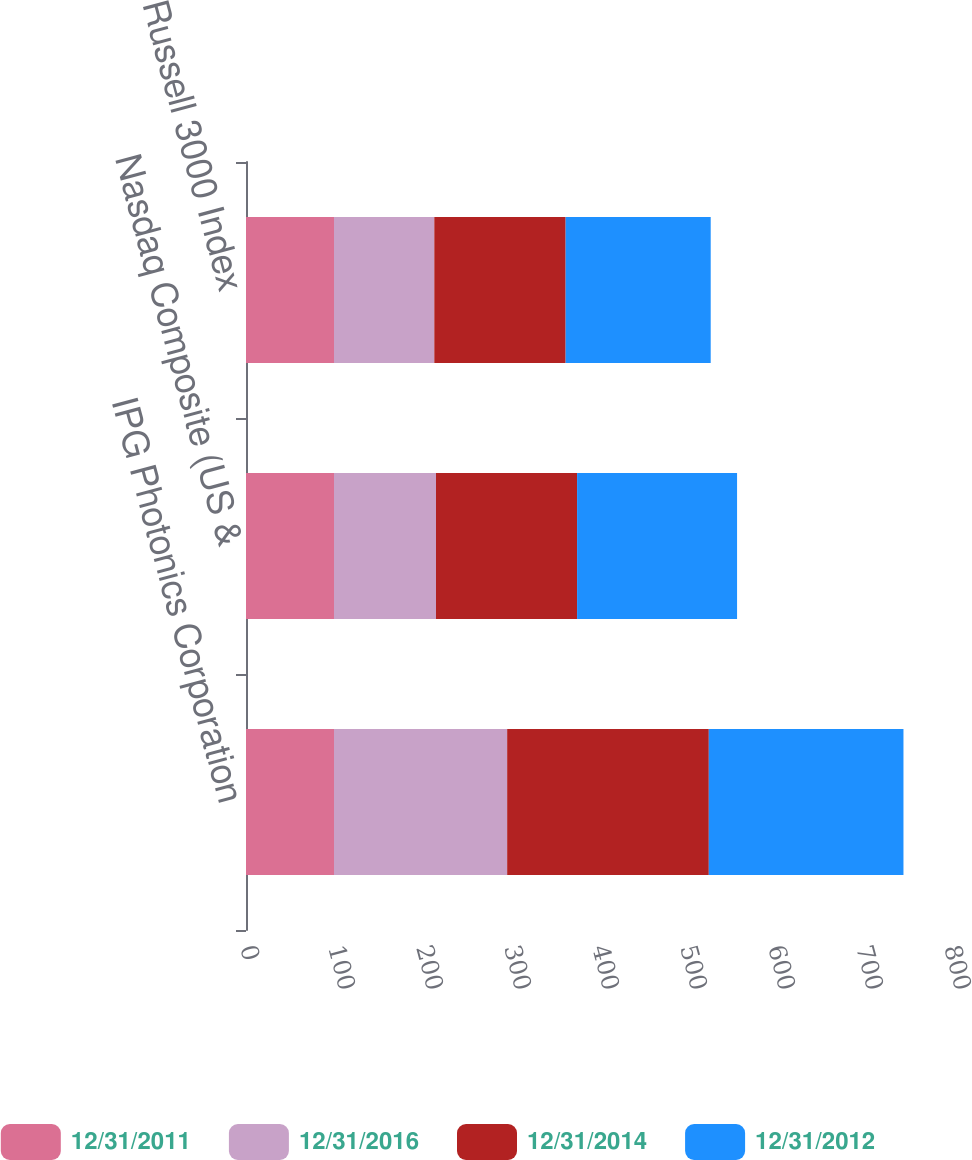Convert chart. <chart><loc_0><loc_0><loc_500><loc_500><stacked_bar_chart><ecel><fcel>IPG Photonics Corporation<fcel>Nasdaq Composite (US &<fcel>Russell 3000 Index<nl><fcel>12/31/2011<fcel>100<fcel>100<fcel>100<nl><fcel>12/31/2016<fcel>196.78<fcel>115.91<fcel>113.98<nl><fcel>12/31/2014<fcel>229.14<fcel>160.32<fcel>149.25<nl><fcel>12/31/2012<fcel>221.2<fcel>181.8<fcel>164.85<nl></chart> 